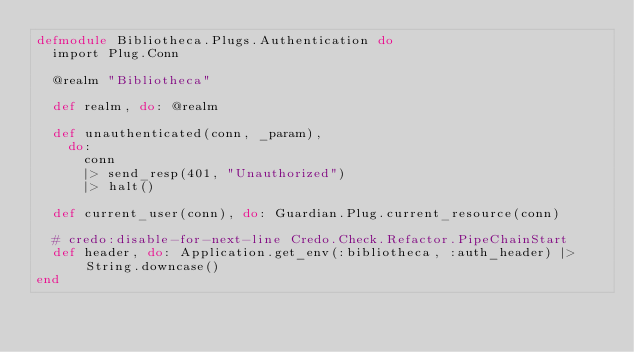Convert code to text. <code><loc_0><loc_0><loc_500><loc_500><_Elixir_>defmodule Bibliotheca.Plugs.Authentication do
  import Plug.Conn

  @realm "Bibliotheca"

  def realm, do: @realm

  def unauthenticated(conn, _param),
    do:
      conn
      |> send_resp(401, "Unauthorized")
      |> halt()

  def current_user(conn), do: Guardian.Plug.current_resource(conn)

  # credo:disable-for-next-line Credo.Check.Refactor.PipeChainStart
  def header, do: Application.get_env(:bibliotheca, :auth_header) |> String.downcase()
end
</code> 